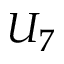Convert formula to latex. <formula><loc_0><loc_0><loc_500><loc_500>U _ { 7 }</formula> 